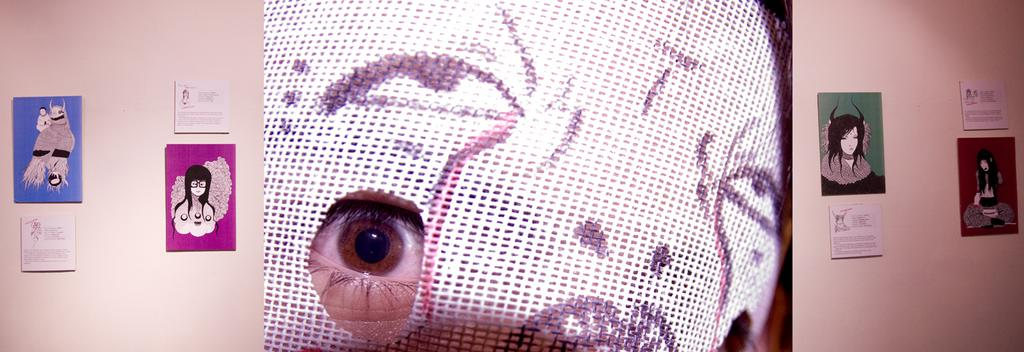Who or what is present in the image? There is a person in the image. What is the person wearing? The person is wearing a mask. What can be seen on the wall in the image? There are wall hangings attached to the wall in the image. What letters can be seen on the quince in the image? There is no quince or letters present in the image. 